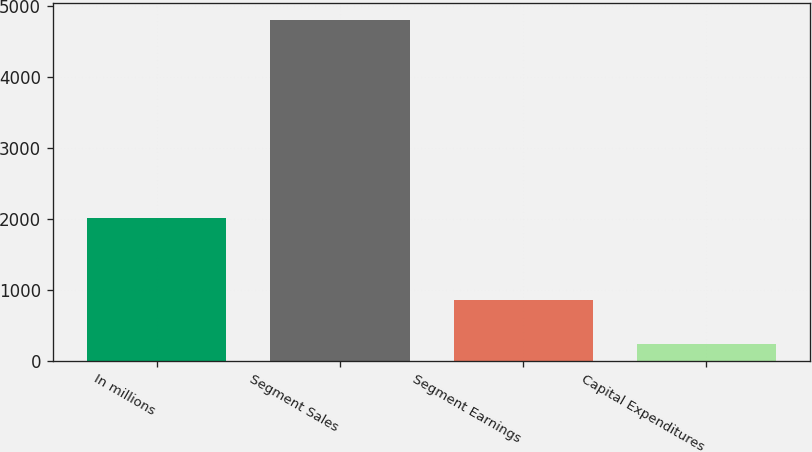Convert chart. <chart><loc_0><loc_0><loc_500><loc_500><bar_chart><fcel>In millions<fcel>Segment Sales<fcel>Segment Earnings<fcel>Capital Expenditures<nl><fcel>2011<fcel>4815<fcel>861<fcel>234<nl></chart> 